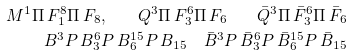<formula> <loc_0><loc_0><loc_500><loc_500>M ^ { 1 } \Pi \, F _ { 1 } ^ { 8 } \Pi \, F _ { 8 } , \quad Q ^ { 3 } \Pi \, F _ { 3 } ^ { 6 } \Pi \, F _ { 6 } \quad \bar { Q } ^ { 3 } \Pi \, \bar { F } _ { 3 } ^ { 6 } \Pi \, \bar { F } _ { 6 } \\ B ^ { 3 } P \, B _ { 3 } ^ { 6 } P \, B _ { 6 } ^ { 1 5 } P \, B _ { 1 5 } \quad \bar { B } ^ { 3 } P \, \bar { B } _ { 3 } ^ { 6 } P \, \bar { B } _ { 6 } ^ { 1 5 } P \, \bar { B } _ { 1 5 }</formula> 